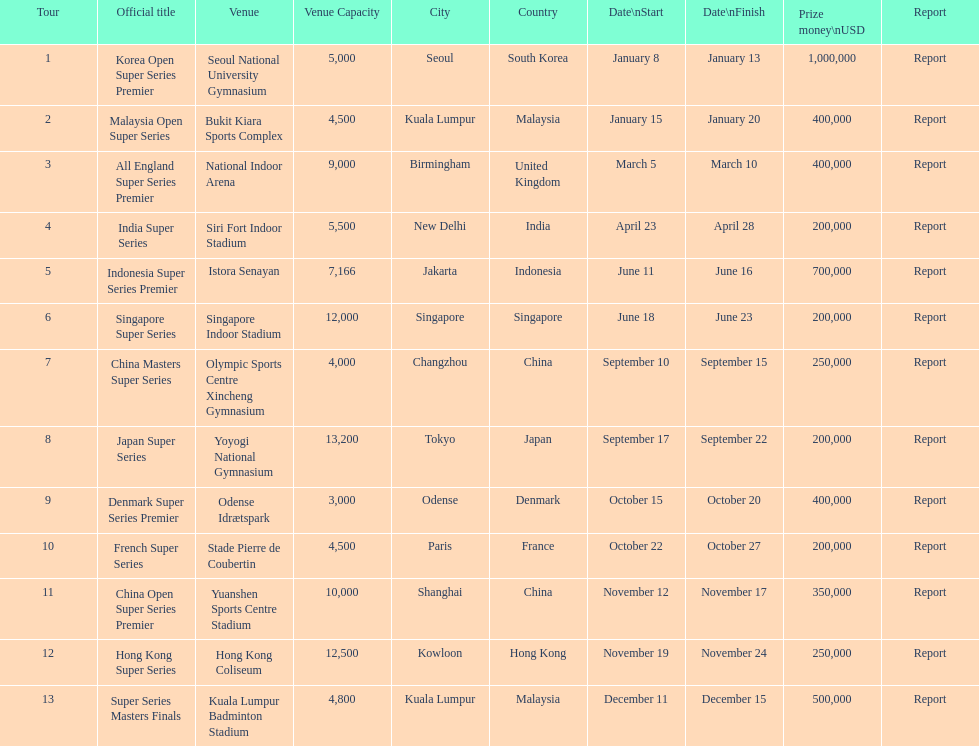How many series secured at least $500,000 in winnings? 3. 